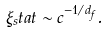Convert formula to latex. <formula><loc_0><loc_0><loc_500><loc_500>\xi _ { s } t a t \sim c ^ { - 1 / d _ { f } } .</formula> 